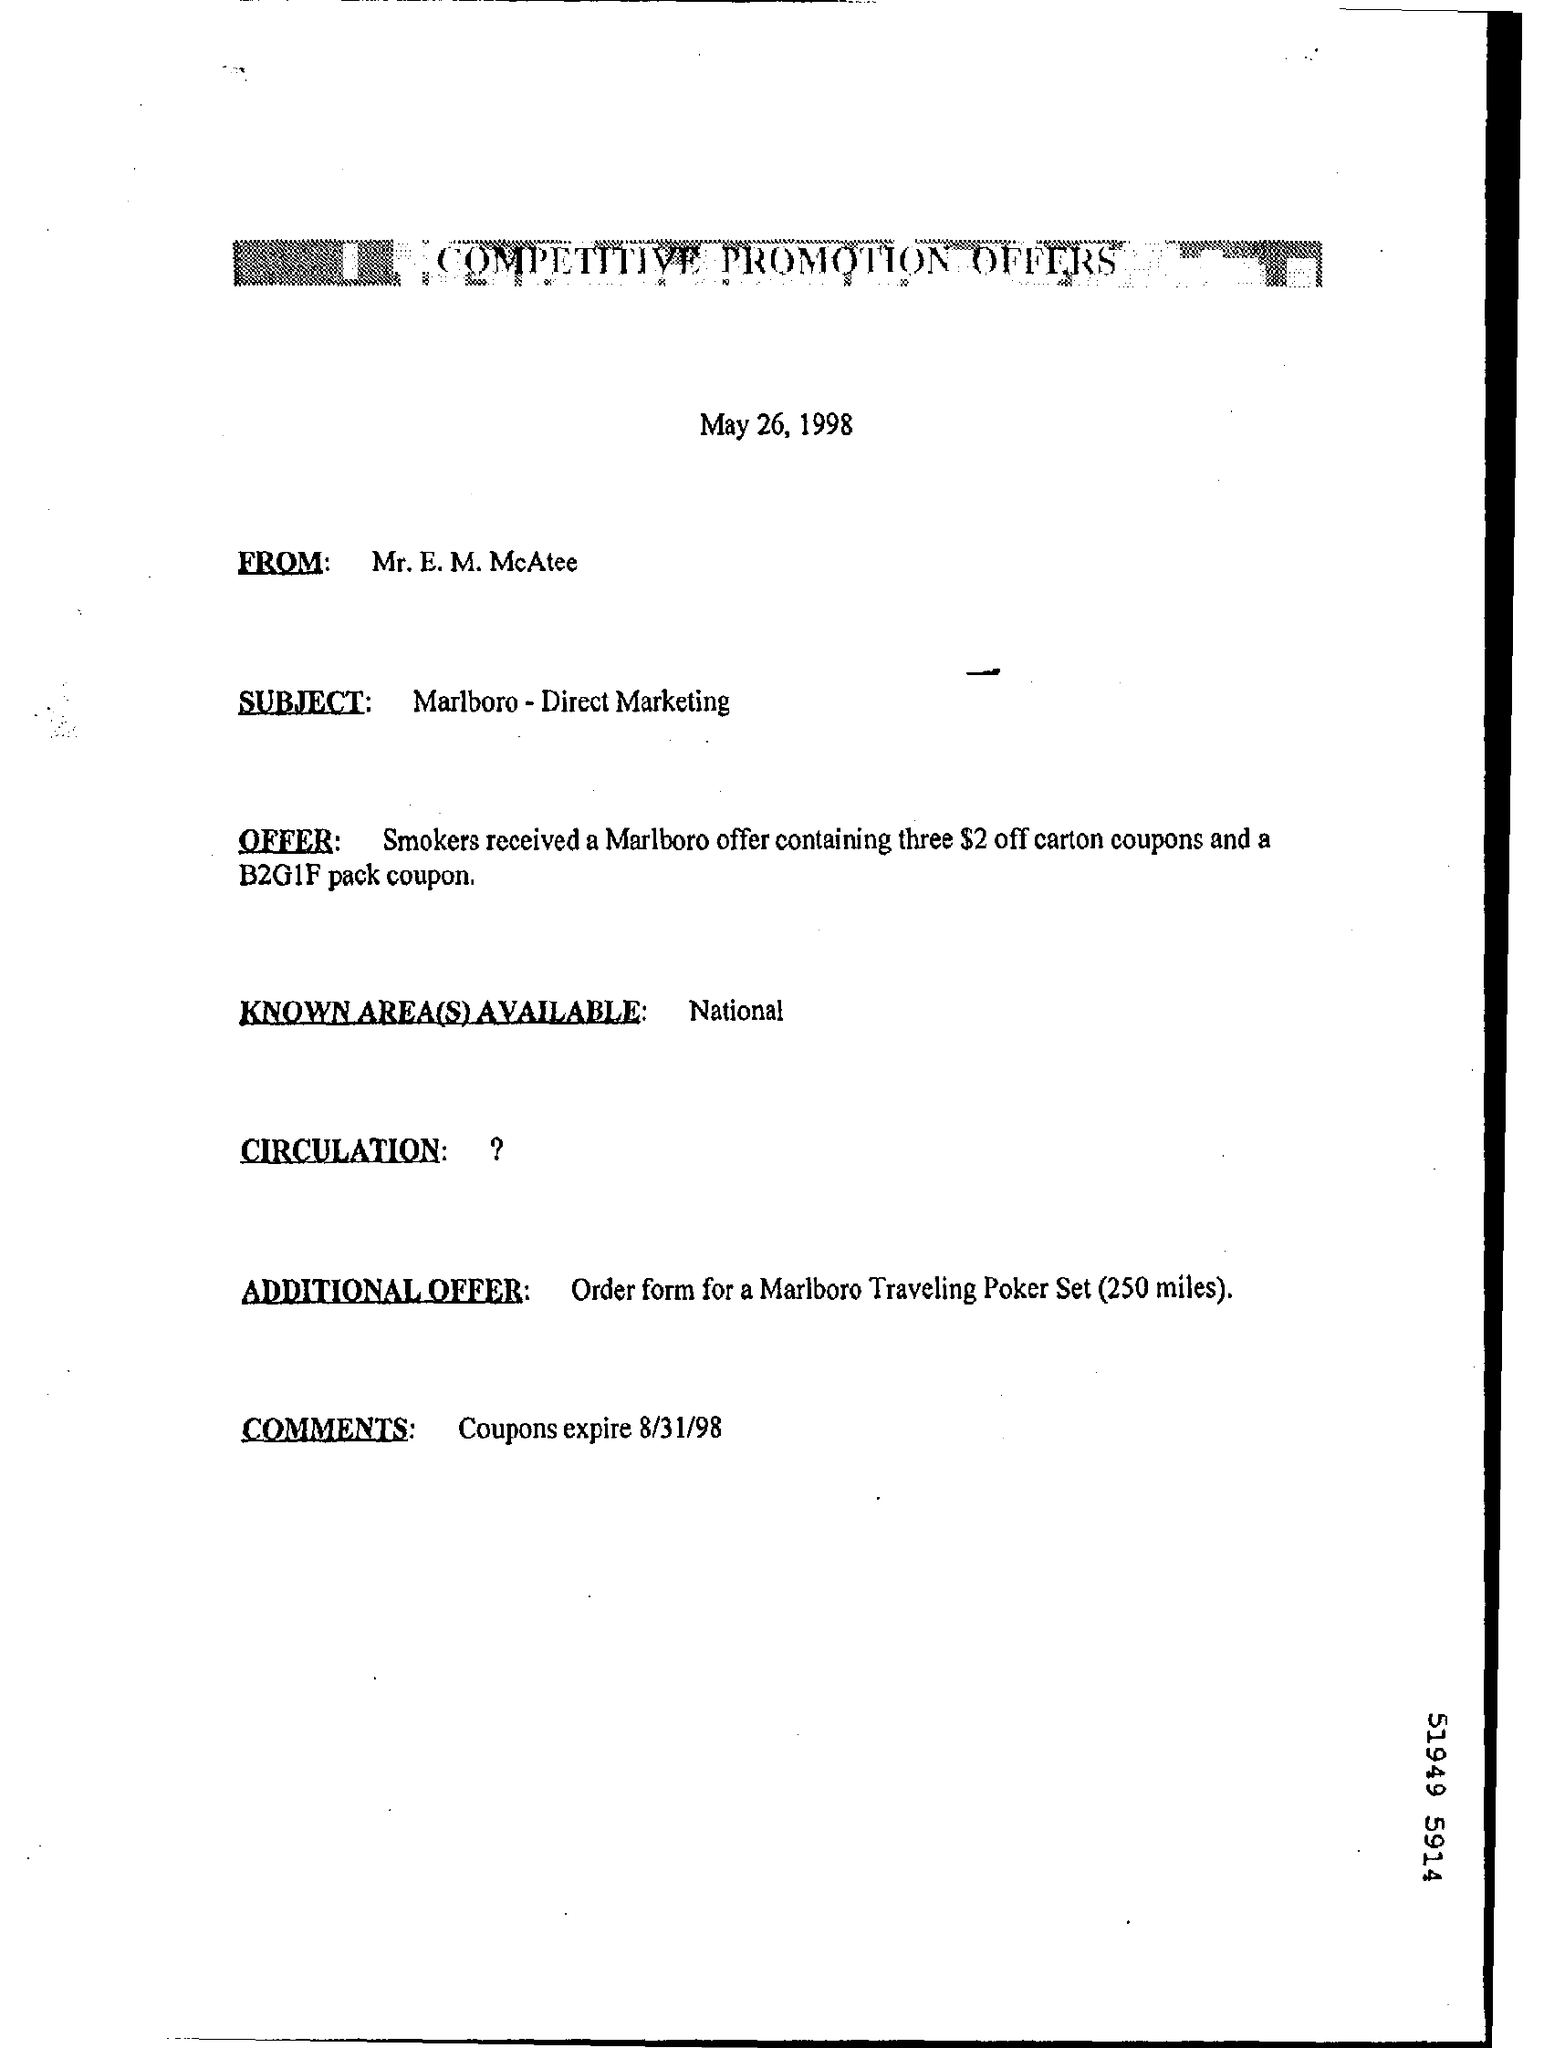Give some essential details in this illustration. The available area(s) are known as National. The coupons will expire on August 31, 1998. The document is dated May 26, 1998. 